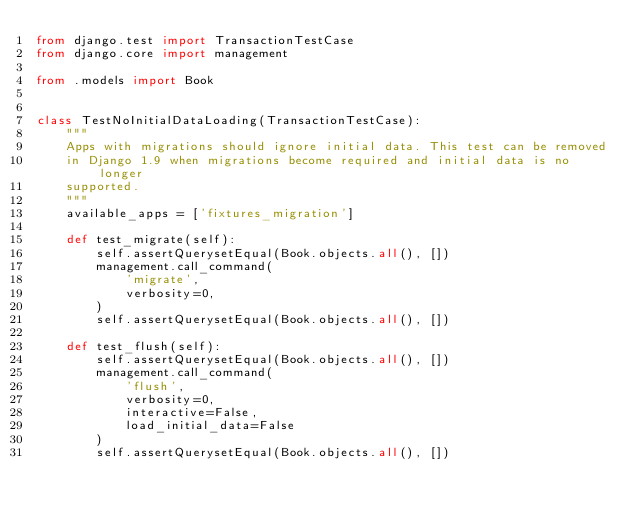Convert code to text. <code><loc_0><loc_0><loc_500><loc_500><_Python_>from django.test import TransactionTestCase
from django.core import management

from .models import Book


class TestNoInitialDataLoading(TransactionTestCase):
    """
    Apps with migrations should ignore initial data. This test can be removed
    in Django 1.9 when migrations become required and initial data is no longer
    supported.
    """
    available_apps = ['fixtures_migration']

    def test_migrate(self):
        self.assertQuerysetEqual(Book.objects.all(), [])
        management.call_command(
            'migrate',
            verbosity=0,
        )
        self.assertQuerysetEqual(Book.objects.all(), [])

    def test_flush(self):
        self.assertQuerysetEqual(Book.objects.all(), [])
        management.call_command(
            'flush',
            verbosity=0,
            interactive=False,
            load_initial_data=False
        )
        self.assertQuerysetEqual(Book.objects.all(), [])
</code> 